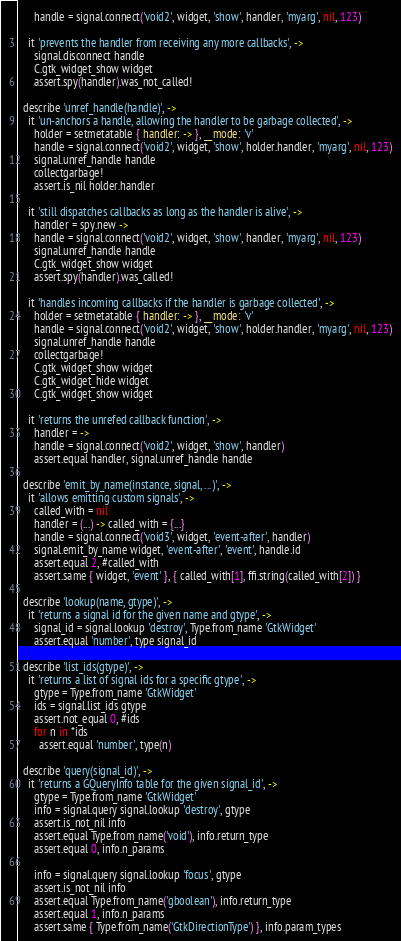<code> <loc_0><loc_0><loc_500><loc_500><_MoonScript_>      handle = signal.connect('void2', widget, 'show', handler, 'myarg', nil, 123)

    it 'prevents the handler from receiving any more callbacks', ->
      signal.disconnect handle
      C.gtk_widget_show widget
      assert.spy(handler).was_not_called!

  describe 'unref_handle(handle)', ->
    it 'un-anchors a handle, allowing the handler to be garbage collected', ->
      holder = setmetatable { handler: -> }, __mode: 'v'
      handle = signal.connect('void2', widget, 'show', holder.handler, 'myarg', nil, 123)
      signal.unref_handle handle
      collectgarbage!
      assert.is_nil holder.handler

    it 'still dispatches callbacks as long as the handler is alive', ->
      handler = spy.new ->
      handle = signal.connect('void2', widget, 'show', handler, 'myarg', nil, 123)
      signal.unref_handle handle
      C.gtk_widget_show widget
      assert.spy(handler).was_called!

    it 'handles incoming callbacks if the handler is garbage collected', ->
      holder = setmetatable { handler: -> }, __mode: 'v'
      handle = signal.connect('void2', widget, 'show', holder.handler, 'myarg', nil, 123)
      signal.unref_handle handle
      collectgarbage!
      C.gtk_widget_show widget
      C.gtk_widget_hide widget
      C.gtk_widget_show widget

    it 'returns the unrefed callback function', ->
      handler = ->
      handle = signal.connect('void2', widget, 'show', handler)
      assert.equal handler, signal.unref_handle handle

  describe 'emit_by_name(instance, signal, ...)', ->
    it 'allows emitting custom signals', ->
      called_with = nil
      handler = (...) -> called_with = {...}
      handle = signal.connect('void3', widget, 'event-after', handler)
      signal.emit_by_name widget, 'event-after', 'event', handle.id
      assert.equal 2, #called_with
      assert.same { widget, 'event' }, { called_with[1], ffi.string(called_with[2]) }

  describe 'lookup(name, gtype)', ->
    it 'returns a signal id for the given name and gtype', ->
      signal_id = signal.lookup 'destroy', Type.from_name 'GtkWidget'
      assert.equal 'number', type signal_id

  describe 'list_ids(gtype)', ->
    it 'returns a list of signal ids for a specific gtype', ->
      gtype = Type.from_name 'GtkWidget'
      ids = signal.list_ids gtype
      assert.not_equal 0, #ids
      for n in *ids
        assert.equal 'number', type(n)

  describe 'query(signal_id)', ->
    it 'returns a GQueryInfo table for the given signal_id', ->
      gtype = Type.from_name 'GtkWidget'
      info = signal.query signal.lookup 'destroy', gtype
      assert.is_not_nil info
      assert.equal Type.from_name('void'), info.return_type
      assert.equal 0, info.n_params

      info = signal.query signal.lookup 'focus', gtype
      assert.is_not_nil info
      assert.equal Type.from_name('gboolean'), info.return_type
      assert.equal 1, info.n_params
      assert.same { Type.from_name('GtkDirectionType') }, info.param_types
</code> 